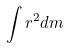<formula> <loc_0><loc_0><loc_500><loc_500>\int r ^ { 2 } d m</formula> 